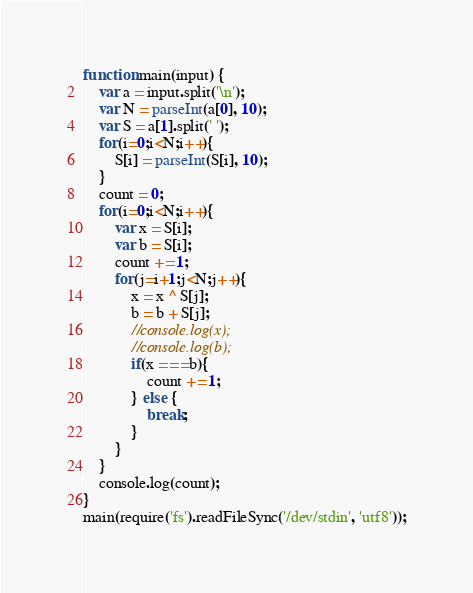<code> <loc_0><loc_0><loc_500><loc_500><_JavaScript_>function main(input) {
	var a = input.split('\n');
	var N = parseInt(a[0], 10);
	var S = a[1].split(' ');
	for(i=0;i<N;i++){
		S[i] = parseInt(S[i], 10);
	}
	count = 0;
	for(i=0;i<N;i++){
		var x = S[i];
		var b = S[i];
		count += 1;
		for(j=i+1;j<N;j++){
			x = x ^ S[j];
			b = b + S[j];
			//console.log(x);
			//console.log(b);
			if(x === b){
				count += 1;
			} else {
				break;
			}
		}
	}
	console.log(count);
}
main(require('fs').readFileSync('/dev/stdin', 'utf8'));</code> 